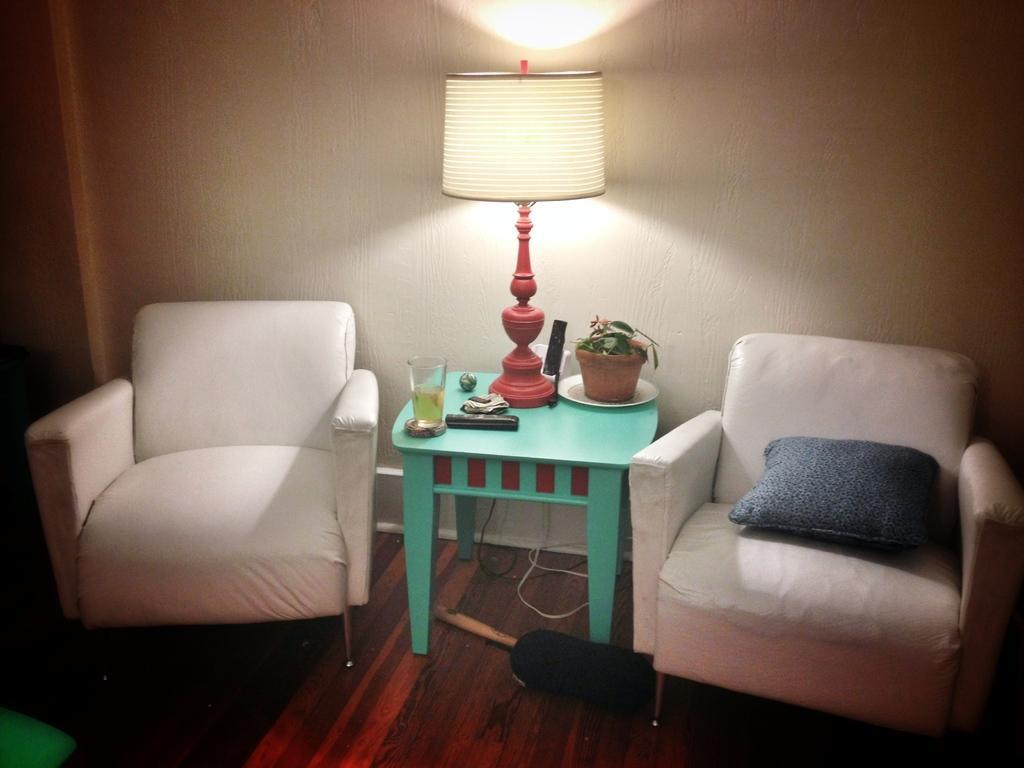How would you summarize this image in a sentence or two? This picture is taken in the room. At the right side there is a sofa and a cushion on it. In the center there is a table and a lamp, house plant and glass on the table. At the left side white colour sofa. In the background there is a wall. 